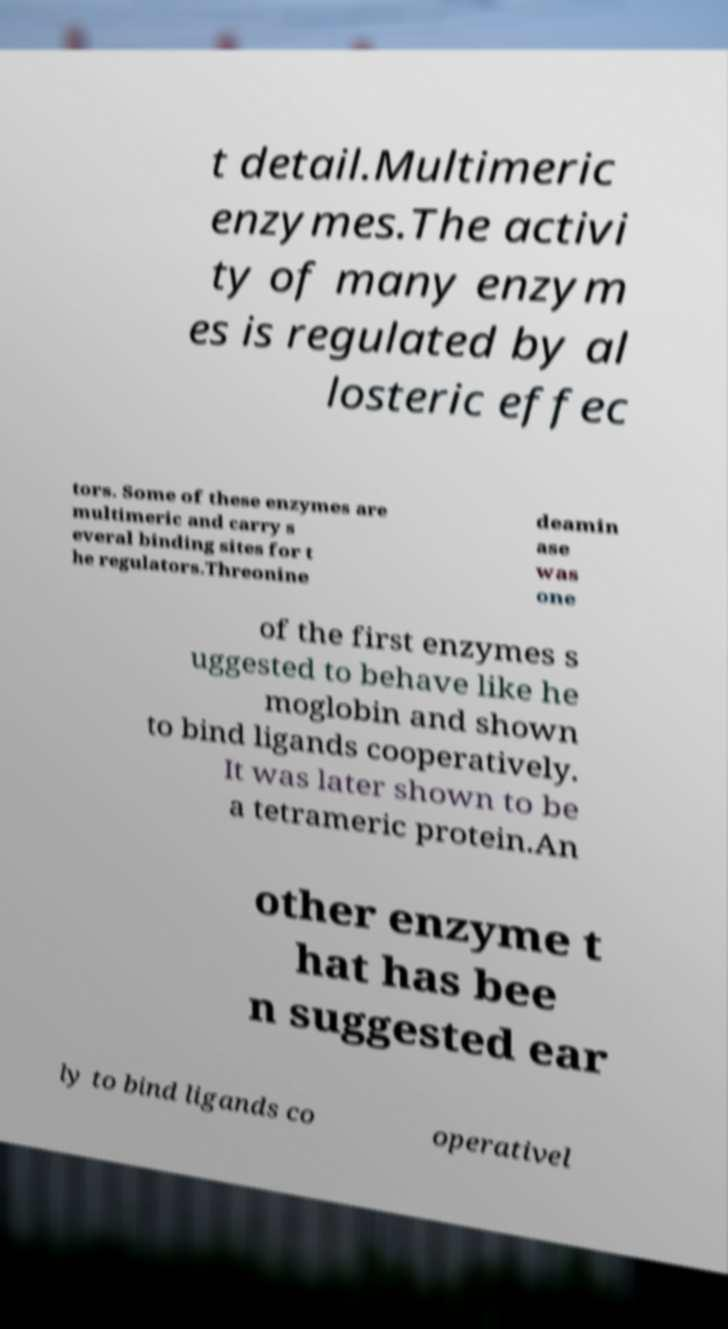I need the written content from this picture converted into text. Can you do that? t detail.Multimeric enzymes.The activi ty of many enzym es is regulated by al losteric effec tors. Some of these enzymes are multimeric and carry s everal binding sites for t he regulators.Threonine deamin ase was one of the first enzymes s uggested to behave like he moglobin and shown to bind ligands cooperatively. It was later shown to be a tetrameric protein.An other enzyme t hat has bee n suggested ear ly to bind ligands co operativel 